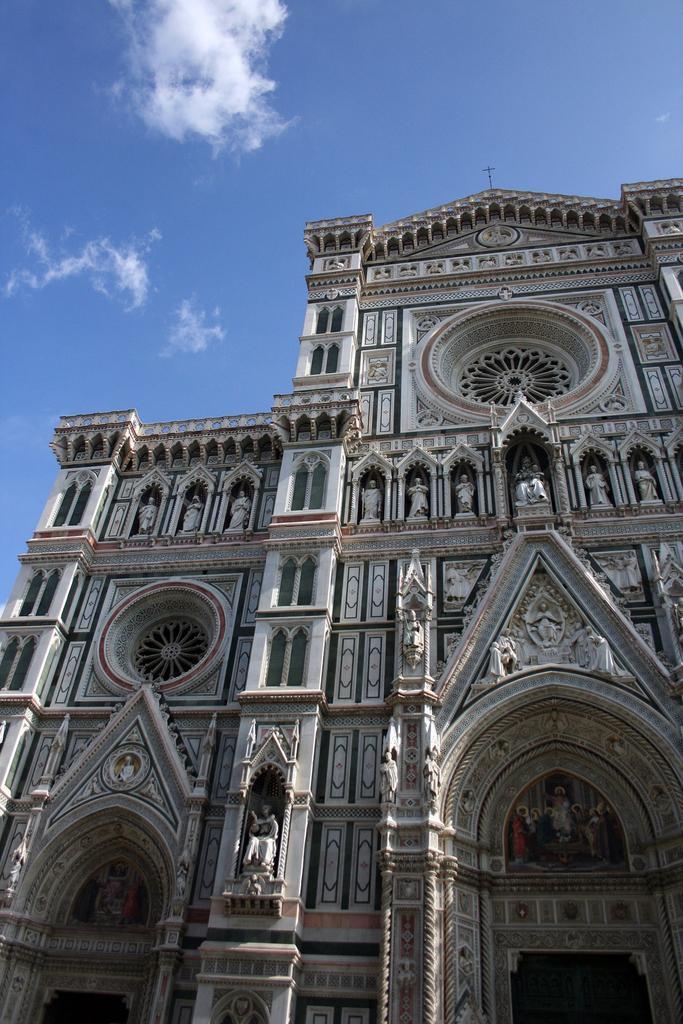Please provide a concise description of this image. This picture shows buildings and we see carvings on the building and few statues and a blue cloudy Sky. 